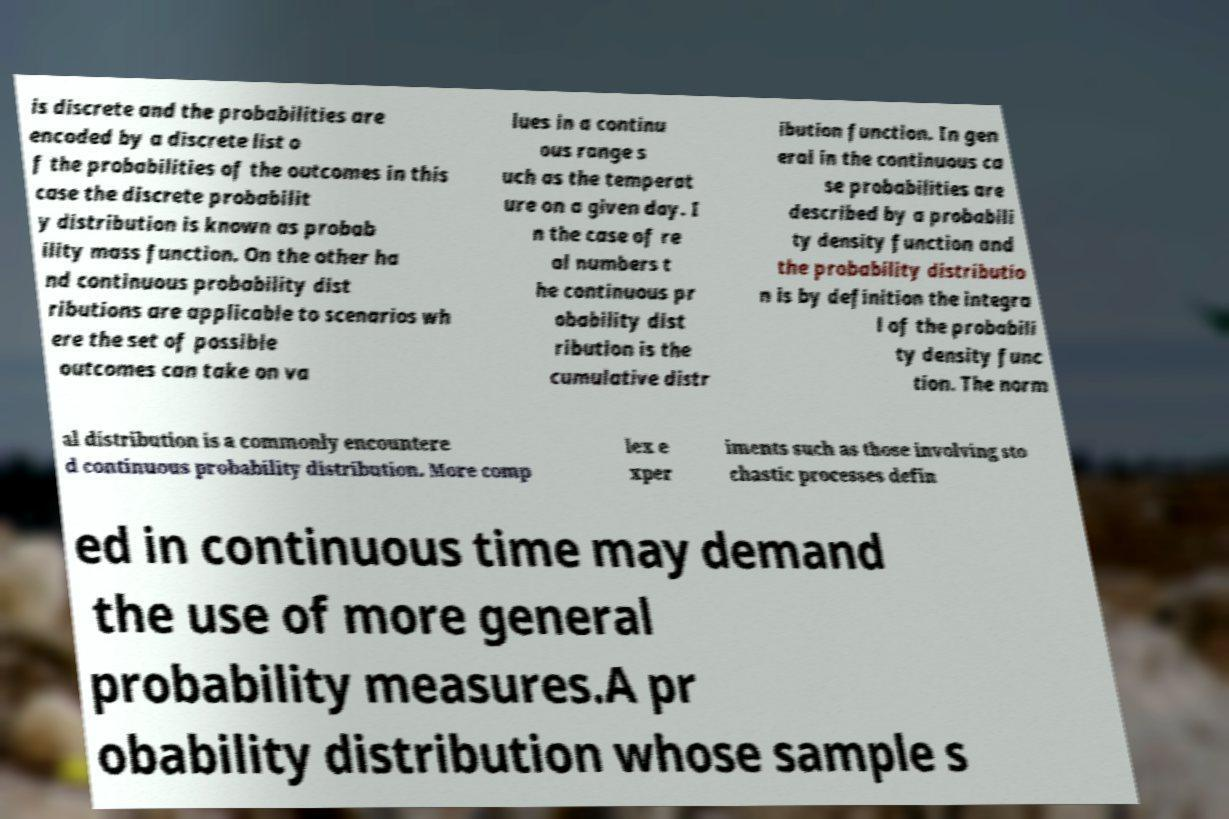For documentation purposes, I need the text within this image transcribed. Could you provide that? is discrete and the probabilities are encoded by a discrete list o f the probabilities of the outcomes in this case the discrete probabilit y distribution is known as probab ility mass function. On the other ha nd continuous probability dist ributions are applicable to scenarios wh ere the set of possible outcomes can take on va lues in a continu ous range s uch as the temperat ure on a given day. I n the case of re al numbers t he continuous pr obability dist ribution is the cumulative distr ibution function. In gen eral in the continuous ca se probabilities are described by a probabili ty density function and the probability distributio n is by definition the integra l of the probabili ty density func tion. The norm al distribution is a commonly encountere d continuous probability distribution. More comp lex e xper iments such as those involving sto chastic processes defin ed in continuous time may demand the use of more general probability measures.A pr obability distribution whose sample s 